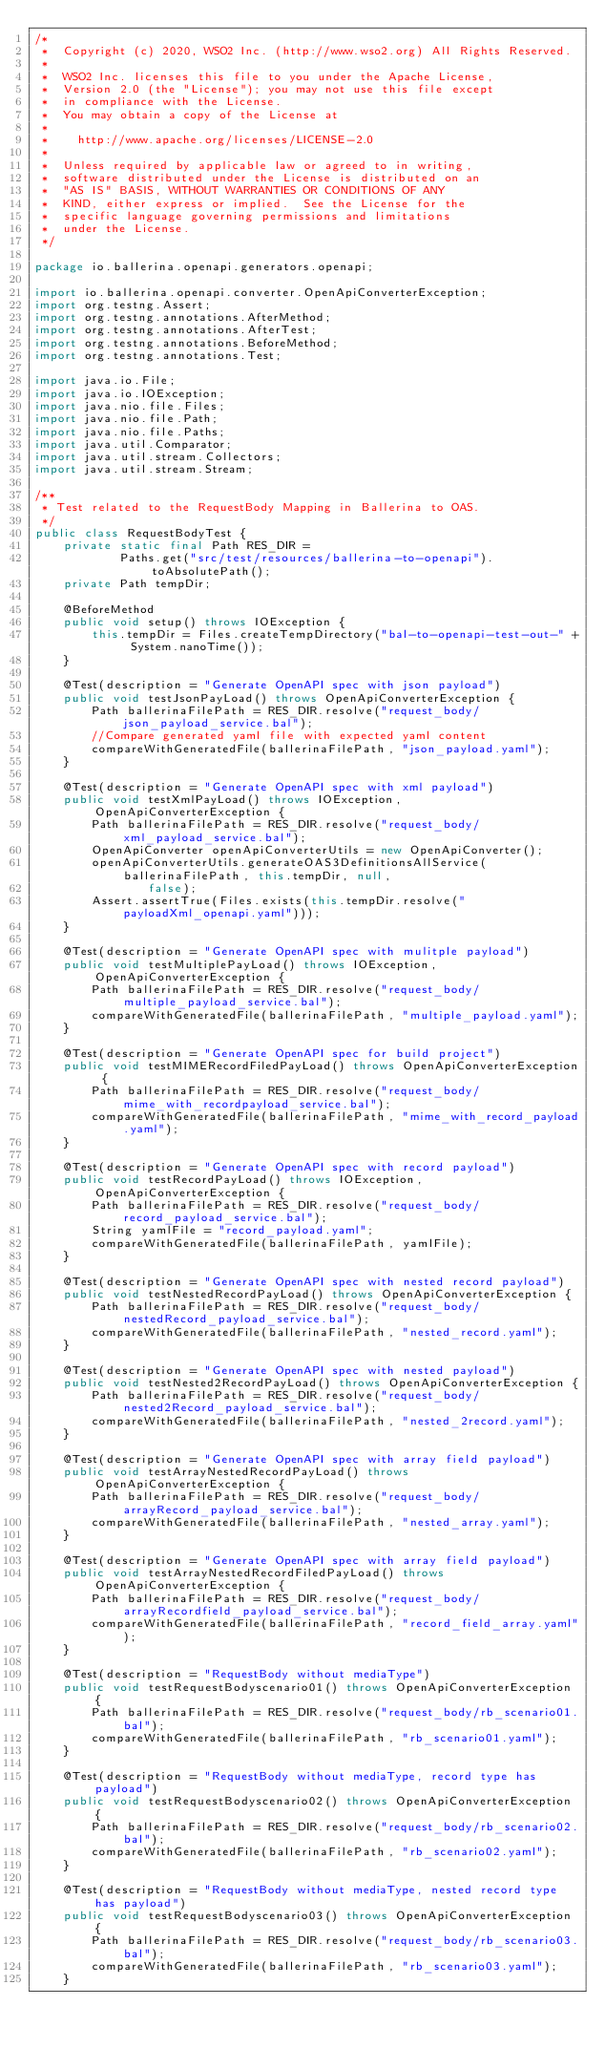Convert code to text. <code><loc_0><loc_0><loc_500><loc_500><_Java_>/*
 *  Copyright (c) 2020, WSO2 Inc. (http://www.wso2.org) All Rights Reserved.
 *
 *  WSO2 Inc. licenses this file to you under the Apache License,
 *  Version 2.0 (the "License"); you may not use this file except
 *  in compliance with the License.
 *  You may obtain a copy of the License at
 *
 *    http://www.apache.org/licenses/LICENSE-2.0
 *
 *  Unless required by applicable law or agreed to in writing,
 *  software distributed under the License is distributed on an
 *  "AS IS" BASIS, WITHOUT WARRANTIES OR CONDITIONS OF ANY
 *  KIND, either express or implied.  See the License for the
 *  specific language governing permissions and limitations
 *  under the License.
 */

package io.ballerina.openapi.generators.openapi;

import io.ballerina.openapi.converter.OpenApiConverterException;
import org.testng.Assert;
import org.testng.annotations.AfterMethod;
import org.testng.annotations.AfterTest;
import org.testng.annotations.BeforeMethod;
import org.testng.annotations.Test;

import java.io.File;
import java.io.IOException;
import java.nio.file.Files;
import java.nio.file.Path;
import java.nio.file.Paths;
import java.util.Comparator;
import java.util.stream.Collectors;
import java.util.stream.Stream;

/**
 * Test related to the RequestBody Mapping in Ballerina to OAS.
 */
public class RequestBodyTest {
    private static final Path RES_DIR =
            Paths.get("src/test/resources/ballerina-to-openapi").toAbsolutePath();
    private Path tempDir;

    @BeforeMethod
    public void setup() throws IOException {
        this.tempDir = Files.createTempDirectory("bal-to-openapi-test-out-" + System.nanoTime());
    }

    @Test(description = "Generate OpenAPI spec with json payload")
    public void testJsonPayLoad() throws OpenApiConverterException {
        Path ballerinaFilePath = RES_DIR.resolve("request_body/json_payload_service.bal");
        //Compare generated yaml file with expected yaml content
        compareWithGeneratedFile(ballerinaFilePath, "json_payload.yaml");
    }

    @Test(description = "Generate OpenAPI spec with xml payload")
    public void testXmlPayLoad() throws IOException, OpenApiConverterException {
        Path ballerinaFilePath = RES_DIR.resolve("request_body/xml_payload_service.bal");
        OpenApiConverter openApiConverterUtils = new OpenApiConverter();
        openApiConverterUtils.generateOAS3DefinitionsAllService(ballerinaFilePath, this.tempDir, null,
                false);
        Assert.assertTrue(Files.exists(this.tempDir.resolve("payloadXml_openapi.yaml")));
    }

    @Test(description = "Generate OpenAPI spec with mulitple payload")
    public void testMultiplePayLoad() throws IOException, OpenApiConverterException {
        Path ballerinaFilePath = RES_DIR.resolve("request_body/multiple_payload_service.bal");
        compareWithGeneratedFile(ballerinaFilePath, "multiple_payload.yaml");
    }

    @Test(description = "Generate OpenAPI spec for build project")
    public void testMIMERecordFiledPayLoad() throws OpenApiConverterException {
        Path ballerinaFilePath = RES_DIR.resolve("request_body/mime_with_recordpayload_service.bal");
        compareWithGeneratedFile(ballerinaFilePath, "mime_with_record_payload.yaml");
    }

    @Test(description = "Generate OpenAPI spec with record payload")
    public void testRecordPayLoad() throws IOException, OpenApiConverterException {
        Path ballerinaFilePath = RES_DIR.resolve("request_body/record_payload_service.bal");
        String yamlFile = "record_payload.yaml";
        compareWithGeneratedFile(ballerinaFilePath, yamlFile);
    }

    @Test(description = "Generate OpenAPI spec with nested record payload")
    public void testNestedRecordPayLoad() throws OpenApiConverterException {
        Path ballerinaFilePath = RES_DIR.resolve("request_body/nestedRecord_payload_service.bal");
        compareWithGeneratedFile(ballerinaFilePath, "nested_record.yaml");
    }

    @Test(description = "Generate OpenAPI spec with nested payload")
    public void testNested2RecordPayLoad() throws OpenApiConverterException {
        Path ballerinaFilePath = RES_DIR.resolve("request_body/nested2Record_payload_service.bal");
        compareWithGeneratedFile(ballerinaFilePath, "nested_2record.yaml");
    }

    @Test(description = "Generate OpenAPI spec with array field payload")
    public void testArrayNestedRecordPayLoad() throws OpenApiConverterException {
        Path ballerinaFilePath = RES_DIR.resolve("request_body/arrayRecord_payload_service.bal");
        compareWithGeneratedFile(ballerinaFilePath, "nested_array.yaml");
    }

    @Test(description = "Generate OpenAPI spec with array field payload")
    public void testArrayNestedRecordFiledPayLoad() throws OpenApiConverterException {
        Path ballerinaFilePath = RES_DIR.resolve("request_body/arrayRecordfield_payload_service.bal");
        compareWithGeneratedFile(ballerinaFilePath, "record_field_array.yaml");
    }

    @Test(description = "RequestBody without mediaType")
    public void testRequestBodyscenario01() throws OpenApiConverterException {
        Path ballerinaFilePath = RES_DIR.resolve("request_body/rb_scenario01.bal");
        compareWithGeneratedFile(ballerinaFilePath, "rb_scenario01.yaml");
    }

    @Test(description = "RequestBody without mediaType, record type has payload")
    public void testRequestBodyscenario02() throws OpenApiConverterException {
        Path ballerinaFilePath = RES_DIR.resolve("request_body/rb_scenario02.bal");
        compareWithGeneratedFile(ballerinaFilePath, "rb_scenario02.yaml");
    }

    @Test(description = "RequestBody without mediaType, nested record type has payload")
    public void testRequestBodyscenario03() throws OpenApiConverterException {
        Path ballerinaFilePath = RES_DIR.resolve("request_body/rb_scenario03.bal");
        compareWithGeneratedFile(ballerinaFilePath, "rb_scenario03.yaml");
    }
</code> 